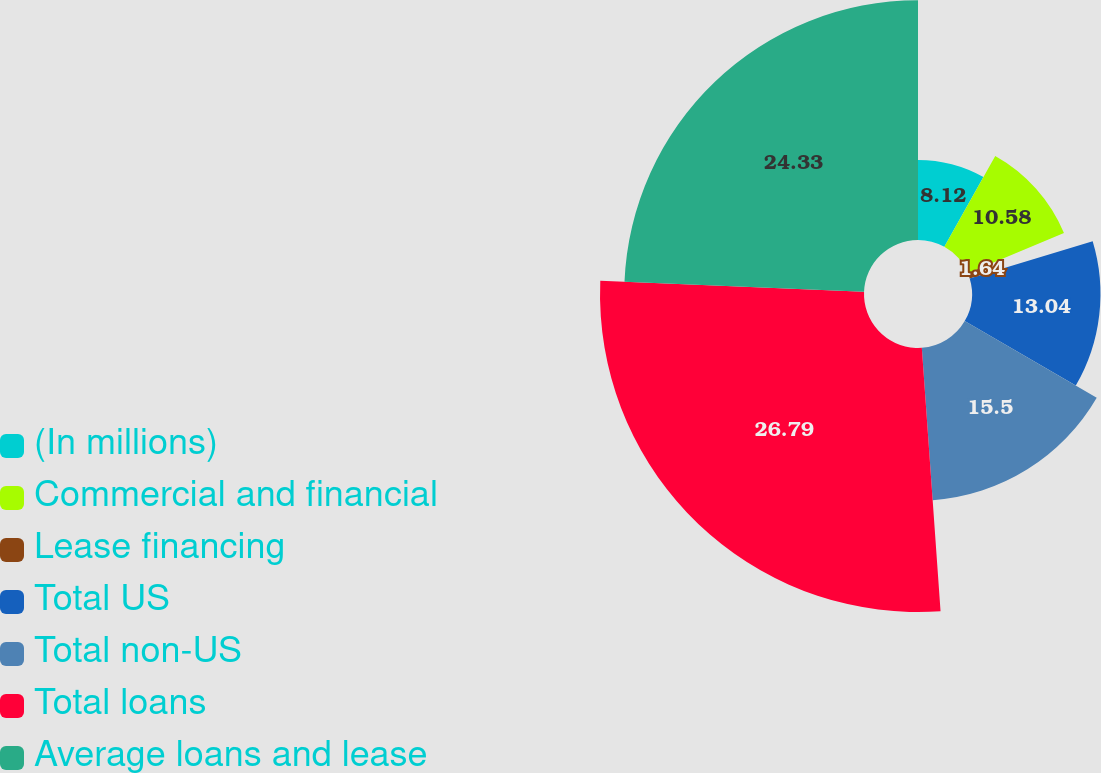Convert chart. <chart><loc_0><loc_0><loc_500><loc_500><pie_chart><fcel>(In millions)<fcel>Commercial and financial<fcel>Lease financing<fcel>Total US<fcel>Total non-US<fcel>Total loans<fcel>Average loans and lease<nl><fcel>8.12%<fcel>10.58%<fcel>1.64%<fcel>13.04%<fcel>15.5%<fcel>26.8%<fcel>24.34%<nl></chart> 